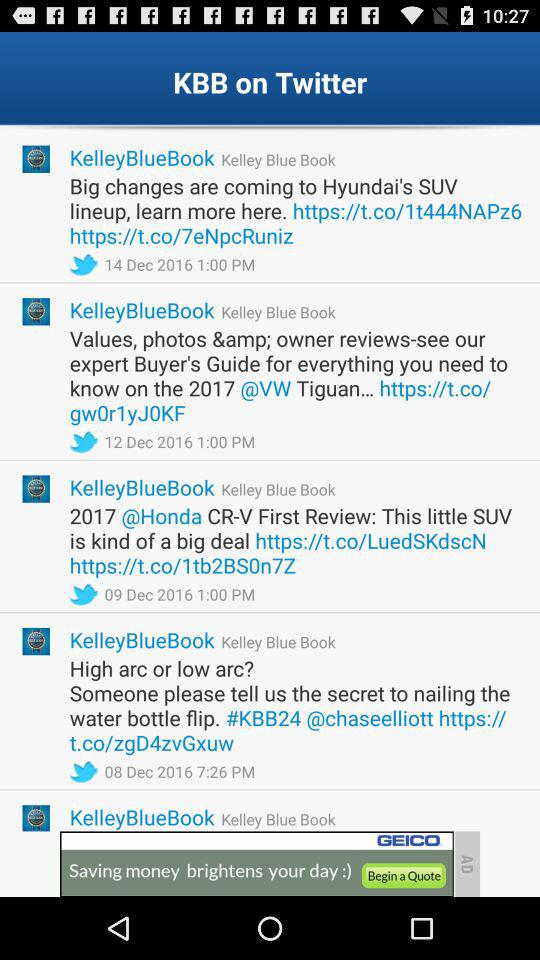What is the "Fair Purchase Price"? The "Fair Purchase Price" is $25,747. 